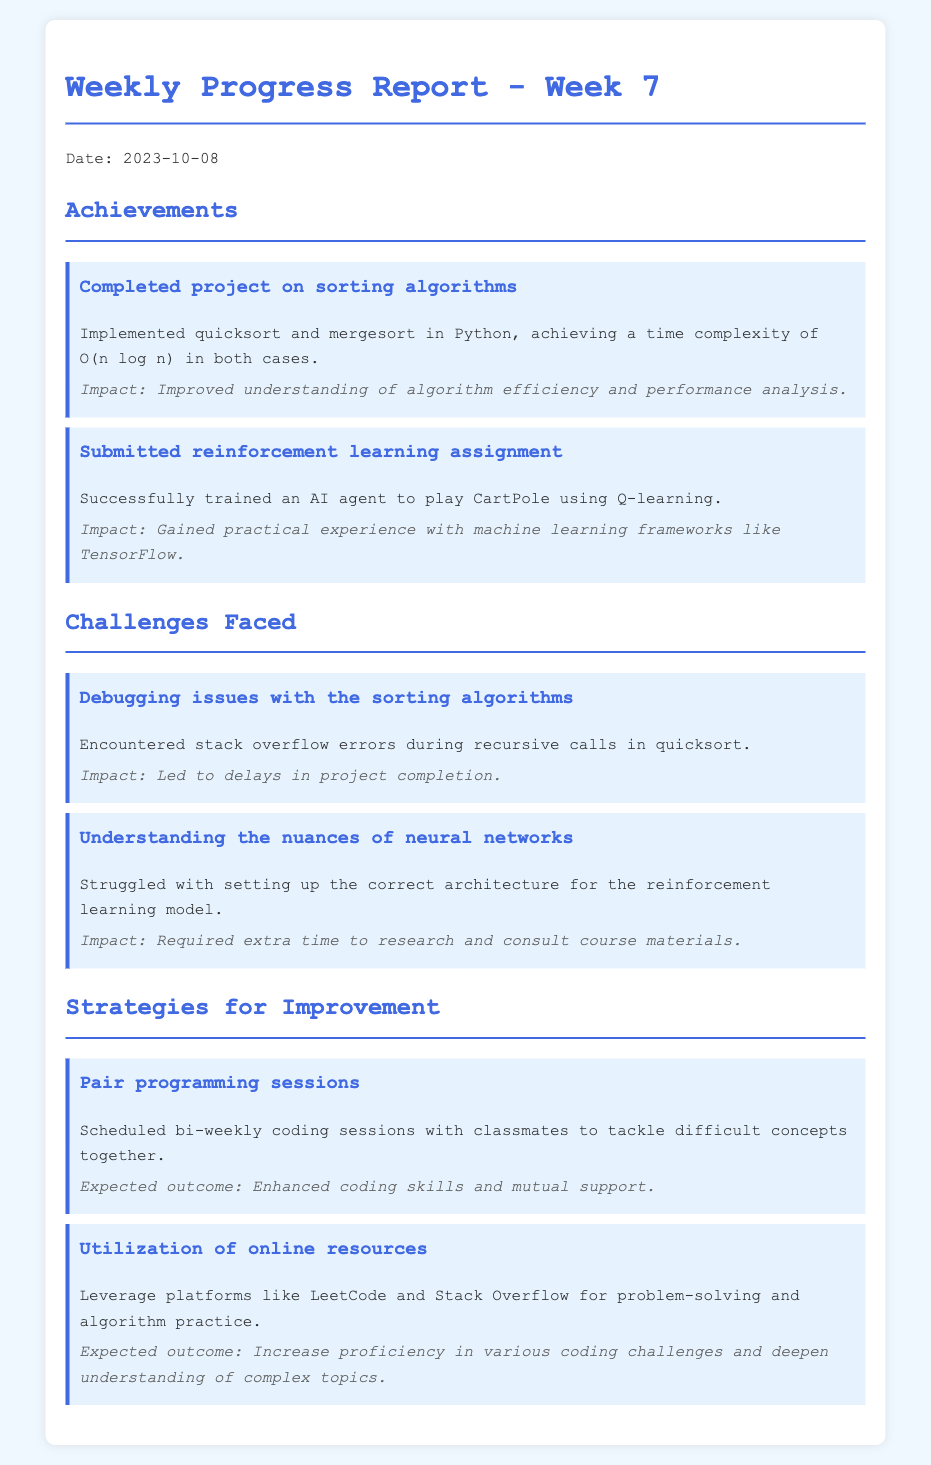What is the date of the report? The date of the report is explicitly mentioned in the document under the heading.
Answer: 2023-10-08 What algorithms were implemented in the project? The document lists the specific algorithms that were completed as part of the achievements section.
Answer: quicksort and mergesort What kind of assignment was submitted? The type of assignment is stated in the achievements section of the document, describing the task completed.
Answer: reinforcement learning What issues were faced during the sorting algorithm project? The challenges faced are detailed in the second section, specifying the types of problems encountered.
Answer: Debugging issues What was the expected outcome of pair programming sessions? The expected outcome is mentioned in the strategies for improvement section, indicating the intended benefits of this strategy.
Answer: Enhanced coding skills and mutual support How did stack overflow errors affect project completion? The impact of the stack overflow errors is described, explaining how they influenced the timeline of the project.
Answer: Led to delays in project completion Which platforms are suggested for online resources? The document specifies the platforms recommended for improving problem-solving and coding practice.
Answer: LeetCode and Stack Overflow What was the impact of struggling with neural networks? This detail summarizes the effects of the challenges faced in understanding neural networks, as noted in the challenges section.
Answer: Required extra time to research and consult course materials 